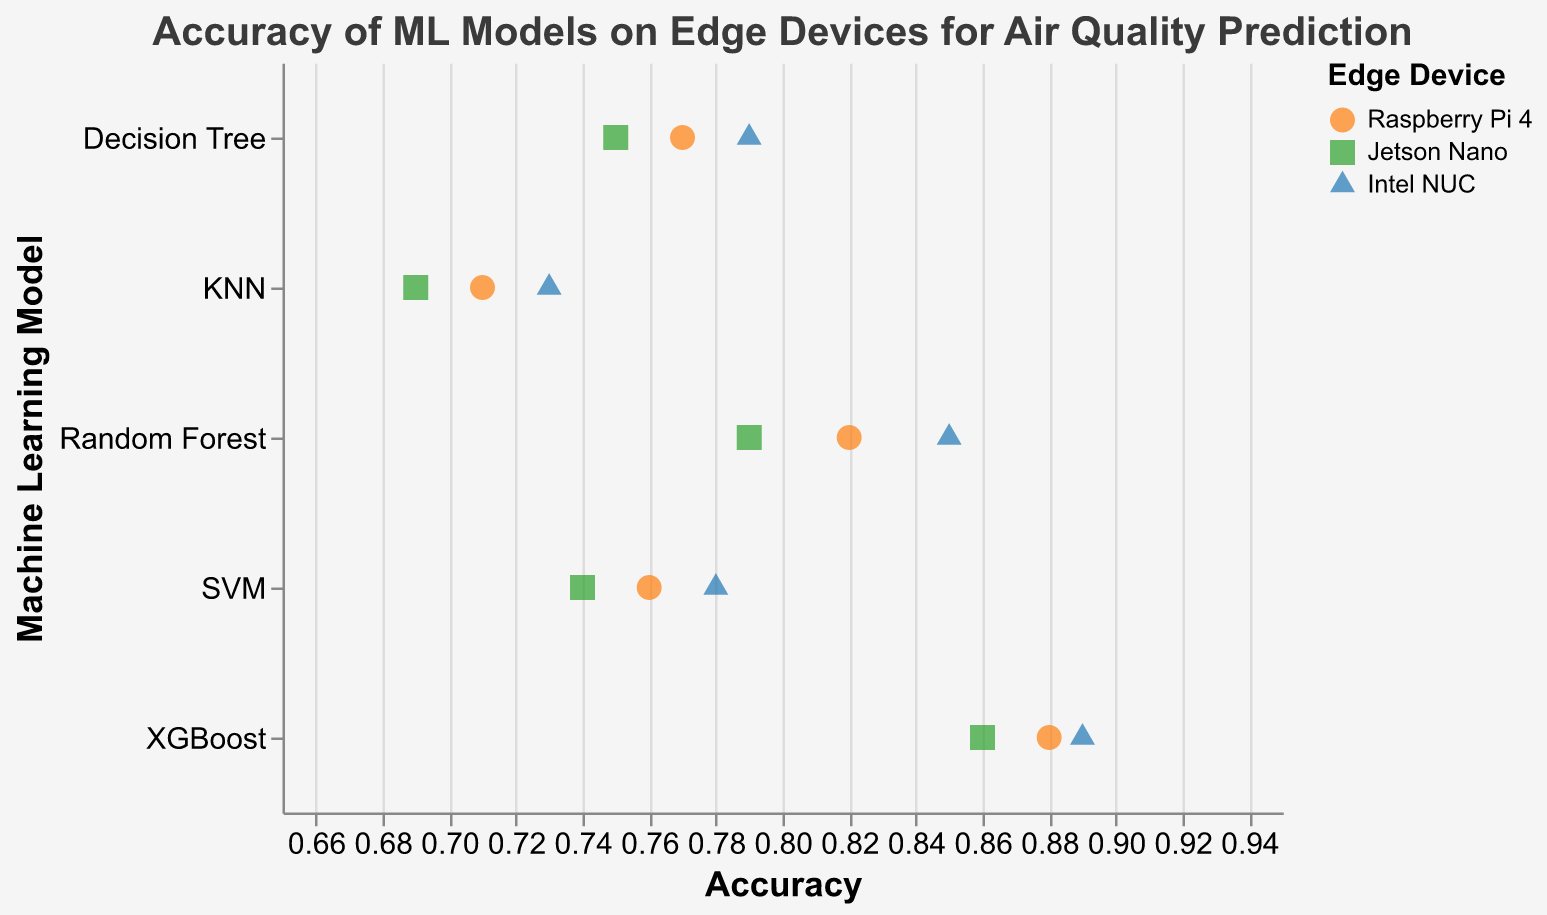what is the title of the chart? The title of the chart is displayed at the top of the figure. It is written in slightly larger font size and descriptive of the content of the plot.
Answer: Accuracy of ML Models on Edge Devices for Air Quality Prediction how many different machine learning models are displayed in the plot? The y-axis of the plot shows the different machine learning models used. By counting the unique model names shown along the y-axis, we can determine the number of different models displayed.
Answer: 5 Which model achieves the highest accuracy? To determine which model achieves the highest accuracy, we look at the x-axis values and find the largest value plotted. The model corresponding to this point will be the one with the highest accuracy.
Answer: XGBoost how does the accuracy of SVM on Intel NUC compare to that on Raspberry Pi 4? We need to find the accuracy values for SVM on both Intel NUC and Raspberry Pi 4 from the plot and compare them directly.
Answer: 0.78 (Intel NUC) vs. 0.76 (Raspberry Pi 4) What is the accuracy range of the KNN model on different devices? The accuracy range refers to the difference between the maximum and minimum accuracy values of the KNN model across all devices. Identify the highest and lowest accuracy values for KNN and compute the difference between them.
Answer: 0.73 - 0.69 = 0.04 Which machine learning model demonstrates the most consistent accuracy across different devices? To determine consistency, we need to look at the difference between the highest and lowest accuracy values for each model across the devices. The smallest difference indicates the most consistency.
Answer: Decision Tree What device shows the highest accuracy for the Random Forest model, and what is its value? Identify the accuracy values for the Random Forest model on each device from the plot, then find the device corresponding to the highest value.
Answer: Intel NUC, 0.85 describe the general trend in accuracy observed for XGBoost across different devices? Examine the point markers associated with the XGBoost model across different devices to describe how the accuracy changes from one device to the next.
Answer: XGBoost shows high accuracy across all devices, with minor differences (Raspberry Pi 4: 0.88, Jetson Nano: 0.86, Intel NUC: 0.89) how many accuracy values for Decision Tree are below 0.78? Count the number of points corresponding to the Decision Tree model that fall below the 0.78 mark on the x-axis.
Answer: 2 Which device shows a wider range of accuracy values across different models? Determine the accuracy range for each device by finding the difference between the highest and lowest accuracy values plotted on that device. The device with the largest range has a wider range of accuracy values.
Answer: Intel NUC 